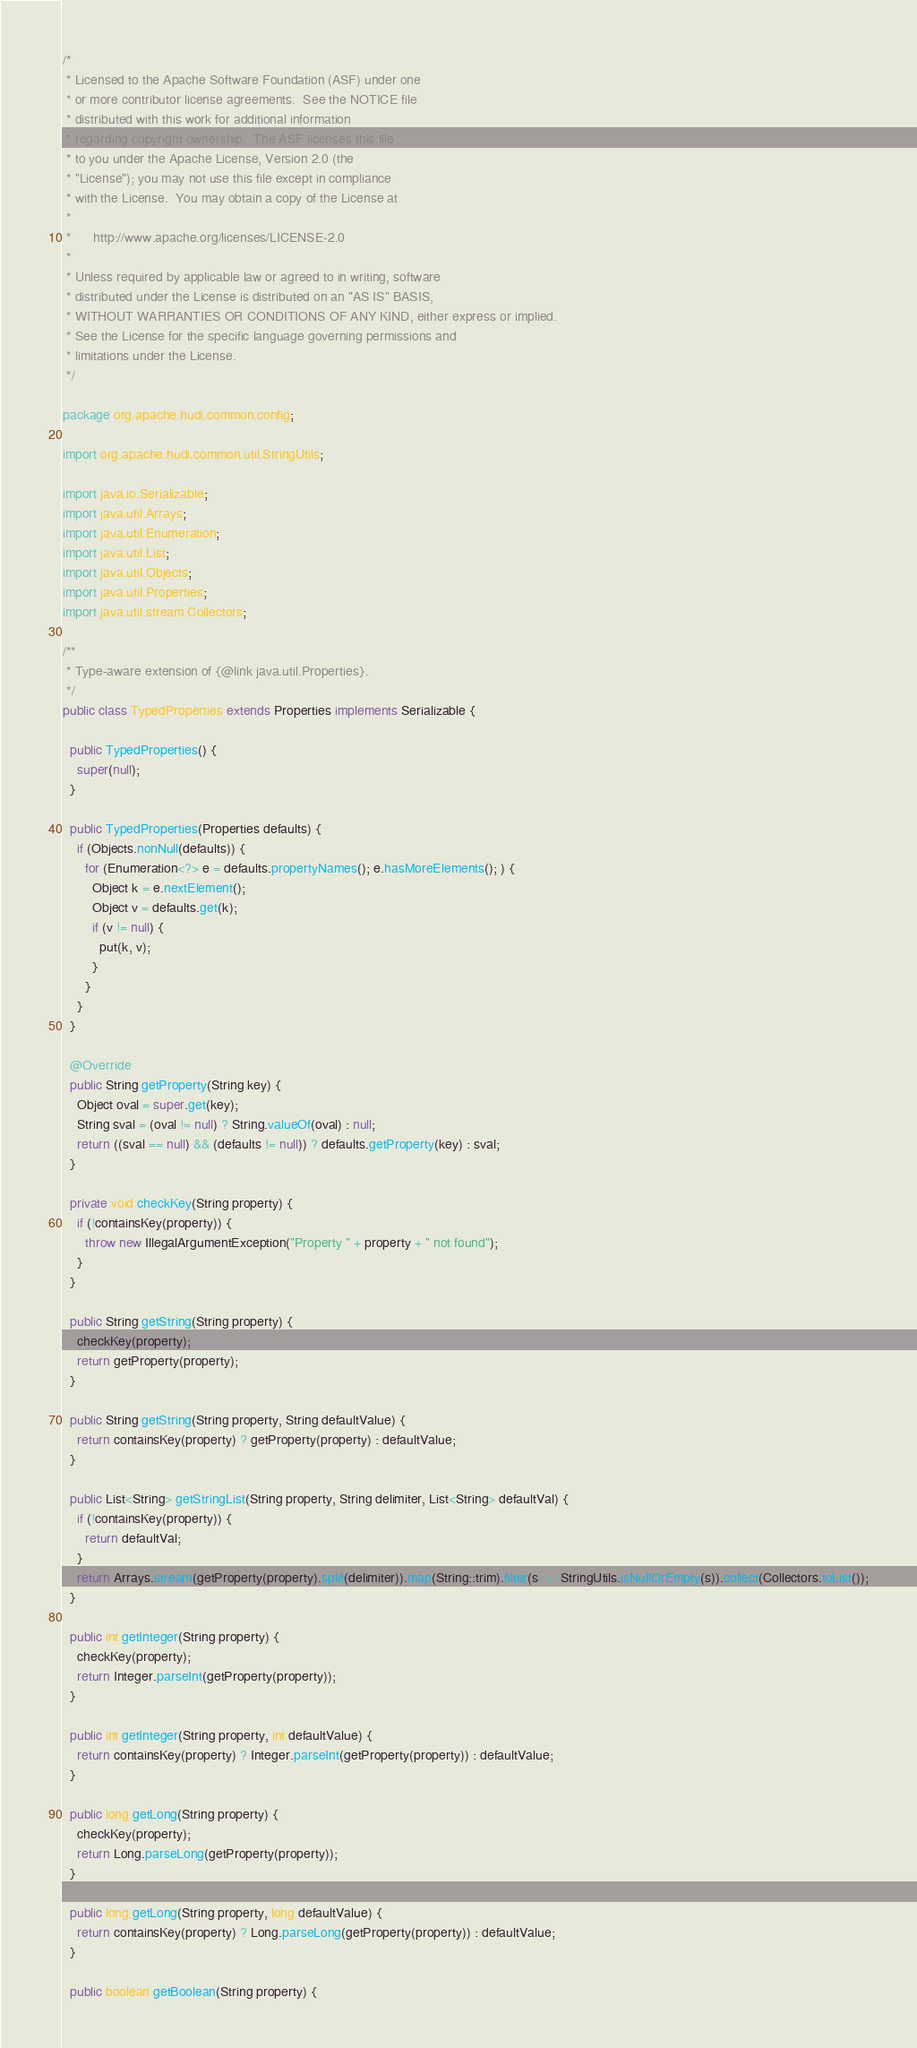<code> <loc_0><loc_0><loc_500><loc_500><_Java_>/*
 * Licensed to the Apache Software Foundation (ASF) under one
 * or more contributor license agreements.  See the NOTICE file
 * distributed with this work for additional information
 * regarding copyright ownership.  The ASF licenses this file
 * to you under the Apache License, Version 2.0 (the
 * "License"); you may not use this file except in compliance
 * with the License.  You may obtain a copy of the License at
 *
 *      http://www.apache.org/licenses/LICENSE-2.0
 *
 * Unless required by applicable law or agreed to in writing, software
 * distributed under the License is distributed on an "AS IS" BASIS,
 * WITHOUT WARRANTIES OR CONDITIONS OF ANY KIND, either express or implied.
 * See the License for the specific language governing permissions and
 * limitations under the License.
 */

package org.apache.hudi.common.config;

import org.apache.hudi.common.util.StringUtils;

import java.io.Serializable;
import java.util.Arrays;
import java.util.Enumeration;
import java.util.List;
import java.util.Objects;
import java.util.Properties;
import java.util.stream.Collectors;

/**
 * Type-aware extension of {@link java.util.Properties}.
 */
public class TypedProperties extends Properties implements Serializable {

  public TypedProperties() {
    super(null);
  }

  public TypedProperties(Properties defaults) {
    if (Objects.nonNull(defaults)) {
      for (Enumeration<?> e = defaults.propertyNames(); e.hasMoreElements(); ) {
        Object k = e.nextElement();
        Object v = defaults.get(k);
        if (v != null) {
          put(k, v);
        }
      }
    }
  }

  @Override
  public String getProperty(String key) {
    Object oval = super.get(key);
    String sval = (oval != null) ? String.valueOf(oval) : null;
    return ((sval == null) && (defaults != null)) ? defaults.getProperty(key) : sval;
  }

  private void checkKey(String property) {
    if (!containsKey(property)) {
      throw new IllegalArgumentException("Property " + property + " not found");
    }
  }

  public String getString(String property) {
    checkKey(property);
    return getProperty(property);
  }

  public String getString(String property, String defaultValue) {
    return containsKey(property) ? getProperty(property) : defaultValue;
  }

  public List<String> getStringList(String property, String delimiter, List<String> defaultVal) {
    if (!containsKey(property)) {
      return defaultVal;
    }
    return Arrays.stream(getProperty(property).split(delimiter)).map(String::trim).filter(s -> !StringUtils.isNullOrEmpty(s)).collect(Collectors.toList());
  }

  public int getInteger(String property) {
    checkKey(property);
    return Integer.parseInt(getProperty(property));
  }

  public int getInteger(String property, int defaultValue) {
    return containsKey(property) ? Integer.parseInt(getProperty(property)) : defaultValue;
  }

  public long getLong(String property) {
    checkKey(property);
    return Long.parseLong(getProperty(property));
  }

  public long getLong(String property, long defaultValue) {
    return containsKey(property) ? Long.parseLong(getProperty(property)) : defaultValue;
  }

  public boolean getBoolean(String property) {</code> 